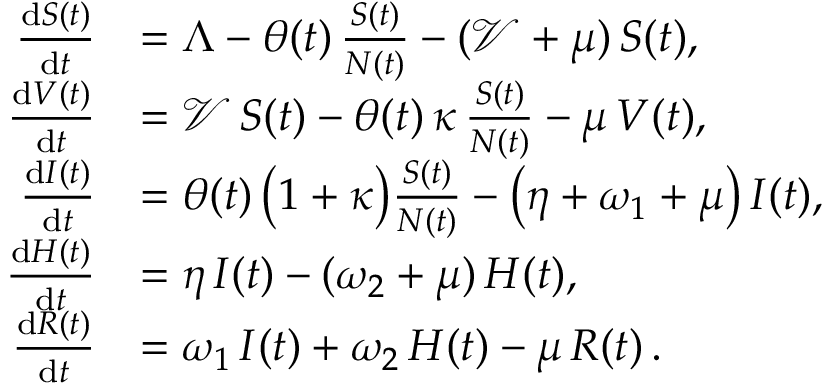<formula> <loc_0><loc_0><loc_500><loc_500>\begin{array} { r l } { \frac { d S ( t ) } { d t } } & { = \Lambda - \theta ( t ) \, \frac { S ( t ) } { N ( t ) } - ( \mathcal { V } + \mu ) \, S ( t ) , } \\ { \frac { d V ( t ) } { d t } } & { = \mathcal { V } \, S ( t ) - \theta ( t ) \, \kappa \, \frac { S ( t ) } { N ( t ) } - \mu \, V ( t ) , } \\ { \frac { d I ( t ) } { d t } } & { = \theta ( t ) \, \left ( 1 + \kappa \right ) \frac { S ( t ) } { N ( t ) } - \left ( \eta + \omega _ { 1 } + \mu \right ) \, I ( t ) , } \\ { \frac { d H ( t ) } { d t } } & { = \eta \, I ( t ) - ( \omega _ { 2 } + \mu ) \, H ( t ) , } \\ { \frac { d R ( t ) } { d t } } & { = \omega _ { 1 } \, I ( t ) + \omega _ { 2 } \, H ( t ) - \mu \, R ( t ) \, . } \end{array}</formula> 